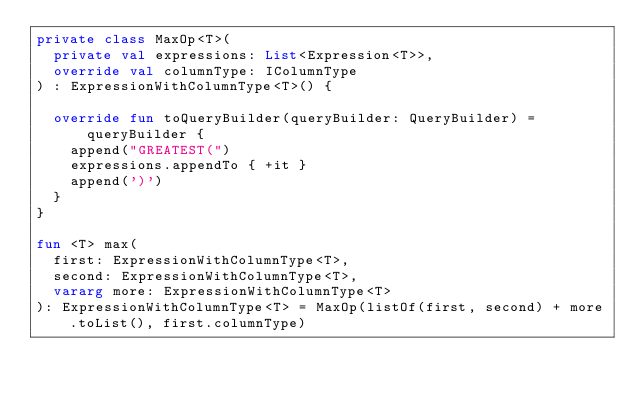Convert code to text. <code><loc_0><loc_0><loc_500><loc_500><_Kotlin_>private class MaxOp<T>(
  private val expressions: List<Expression<T>>,
  override val columnType: IColumnType
) : ExpressionWithColumnType<T>() {

  override fun toQueryBuilder(queryBuilder: QueryBuilder) = queryBuilder {
    append("GREATEST(")
    expressions.appendTo { +it }
    append(')')
  }
}

fun <T> max(
  first: ExpressionWithColumnType<T>,
  second: ExpressionWithColumnType<T>,
  vararg more: ExpressionWithColumnType<T>
): ExpressionWithColumnType<T> = MaxOp(listOf(first, second) + more.toList(), first.columnType)
</code> 